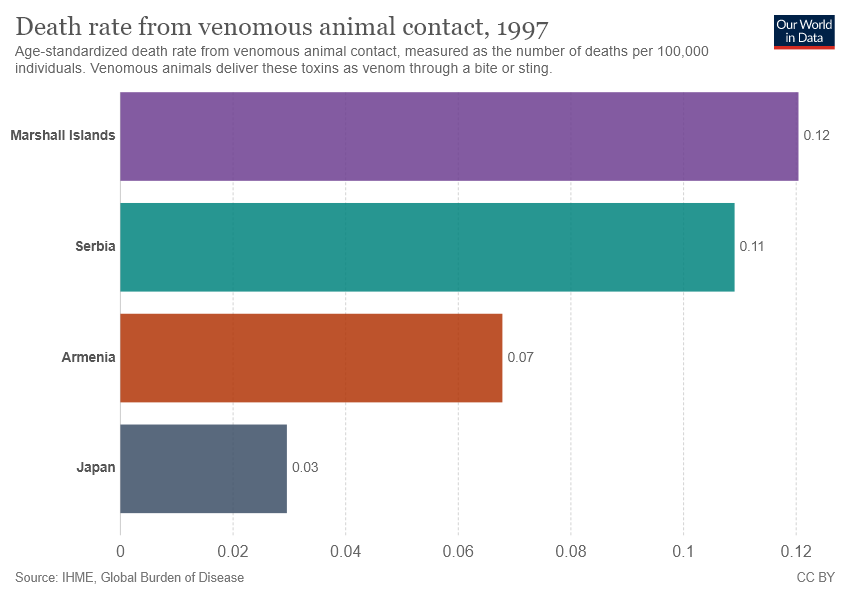Outline some significant characteristics in this image. The Marshall Islands are significantly larger than Japan. What is Japan data?" is a question that is asking for information about data that relates to Japan. The text "0.03.." is an incomplete number or a placeholder, which means that it does not provide a specific number or value. It is likely that the text is intended to represent a decimal value or a range of values, but it is not clear what the value or range represents without additional context. 